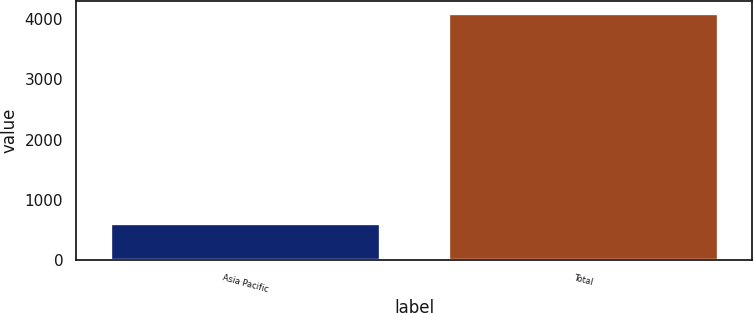Convert chart to OTSL. <chart><loc_0><loc_0><loc_500><loc_500><bar_chart><fcel>Asia Pacific<fcel>Total<nl><fcel>603.8<fcel>4095.4<nl></chart> 